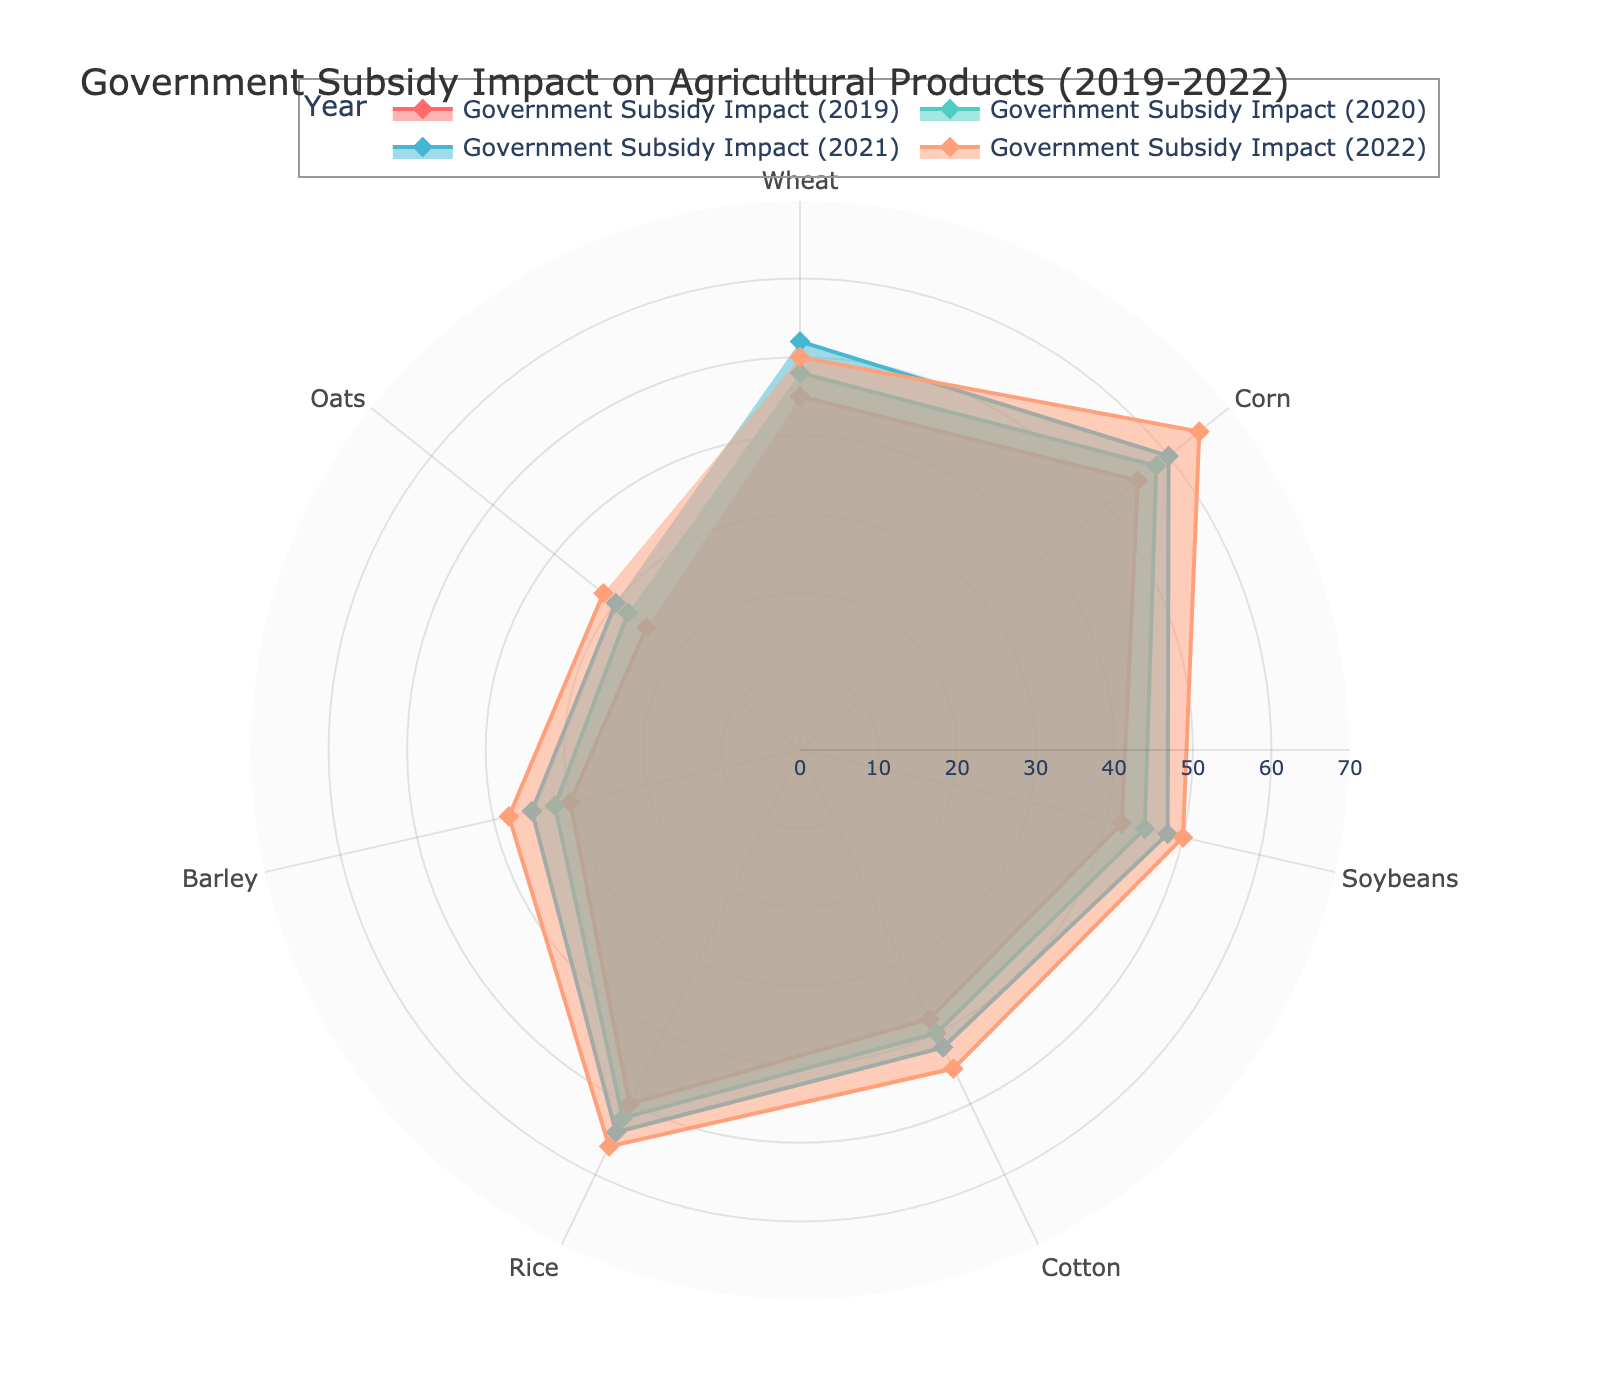What is the title of this radar chart? The title is displayed at the top of the radar chart in larger, bold text, indicating the overall topic of the visualization.
Answer: Government Subsidy Impact on Agricultural Products (2019-2022) Which agricultural product benefitted the most from government subsidies in 2022? By observing the outermost points for the year 2022 (colored differently), identify the highest value. It appears on the outer edge.
Answer: Corn Which year had the most impact on Cotton? Look for the line corresponding to Cotton and trace it to identify which year's subsidy impact is the highest. Cotton has the highest point in the year with the maximum impact.
Answer: 2022 What is the average subsidy impact on Rice over the four years? Calculate the average by summing the subsidy impacts of Rice for all years and dividing by the number of years. (50+52+54+56) / 4 = 53
Answer: 53 Between Wheat and Soybeans, which agricultural product experienced a higher increase in subsidy impact from 2019 to 2022? Calculate the increase for Wheat (50-45) and Soybeans (50-42), then compare the two. Wheat had an increase of 5, and Soybeans had an increase of 8.
Answer: Soybeans Which product had the smallest change in subsidy impact from 2019 to 2022? Determine the change for each product over these years and identify the smallest difference. For Wheat: 50-45=5; Corn: 65-55=10; Soybeans: 50-42=8; Cotton: 45-38=7; Rice: 56-50=6; Barley: 38-30=8; Oats: 32-25=7. The smallest difference is with Wheat.
Answer: Wheat How many agricultural products showed an increasing trend in government subsidies from 2019 to 2022? Assess the direction of change for each product's values over the years. All products (Wheat, Corn, Soybeans, Cotton, Rice, Barley, Oats) increase in subsidy impact from 2019 to 2022.
Answer: 7 Which year had the highest overall impact on all agricultural products? Sum the impacts for each year and compare them. Sum for 2019: 45+55+42+38+50+30+25 = 285; 2020: 48+58+45+40+52+32+28 = 303; 2021: 52+60+48+42+54+35+30 = 321; 2022: 50+65+50+45+56+38+32 = 336. The highest is 2022.
Answer: 2022 When comparing Barley and Oats in 2021, which received a higher subsidy impact? Trace the lines for Barley and Oats to the year 2021 and compare their values. Barley's value is 35 and Oats' value is 30.
Answer: Barley What are the three products with the highest subsidy impact in 2019? List them in descending order. Identify the highest values for 2019 and list the corresponding products. The highest are Corn (55), Rice (50), and Wheat (45).
Answer: Corn, Rice, Wheat 